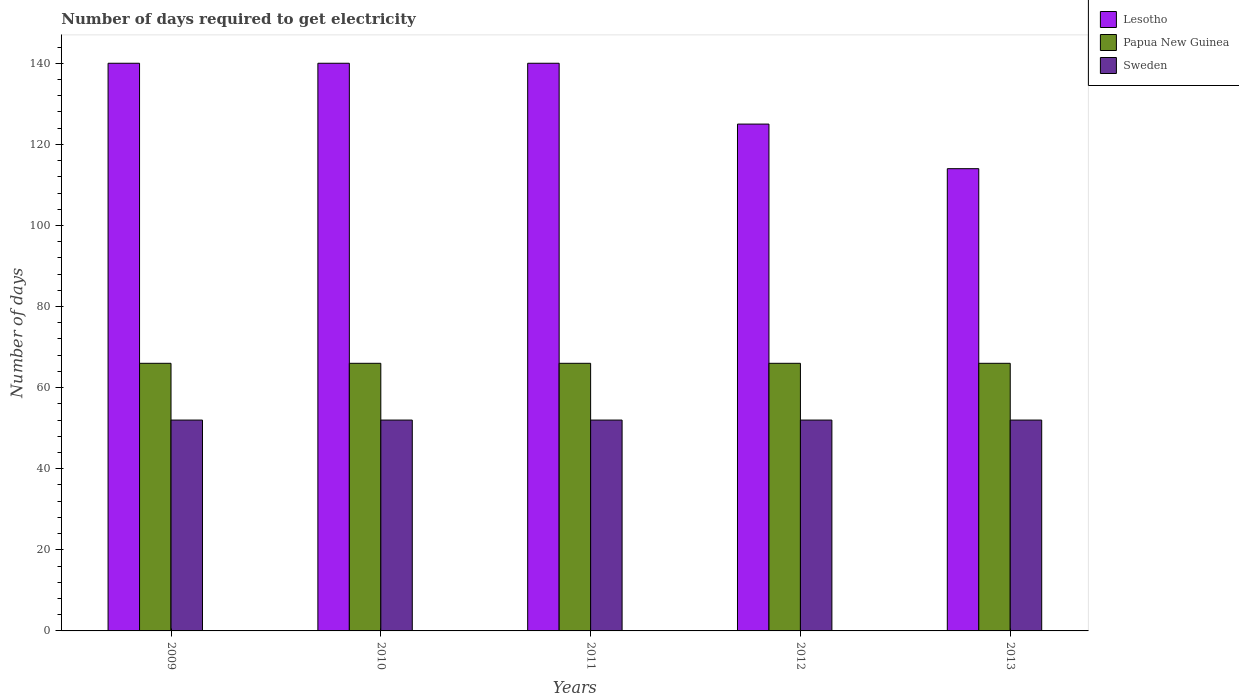Are the number of bars on each tick of the X-axis equal?
Your answer should be compact. Yes. How many bars are there on the 4th tick from the right?
Give a very brief answer. 3. In how many cases, is the number of bars for a given year not equal to the number of legend labels?
Keep it short and to the point. 0. What is the number of days required to get electricity in in Papua New Guinea in 2012?
Offer a very short reply. 66. Across all years, what is the maximum number of days required to get electricity in in Papua New Guinea?
Your answer should be compact. 66. Across all years, what is the minimum number of days required to get electricity in in Papua New Guinea?
Your answer should be compact. 66. In which year was the number of days required to get electricity in in Papua New Guinea maximum?
Keep it short and to the point. 2009. What is the total number of days required to get electricity in in Lesotho in the graph?
Keep it short and to the point. 659. What is the difference between the number of days required to get electricity in in Papua New Guinea in 2010 and that in 2013?
Give a very brief answer. 0. What is the difference between the number of days required to get electricity in in Papua New Guinea in 2011 and the number of days required to get electricity in in Lesotho in 2012?
Make the answer very short. -59. What is the average number of days required to get electricity in in Papua New Guinea per year?
Ensure brevity in your answer.  66. In the year 2011, what is the difference between the number of days required to get electricity in in Sweden and number of days required to get electricity in in Papua New Guinea?
Offer a very short reply. -14. What is the ratio of the number of days required to get electricity in in Sweden in 2011 to that in 2012?
Make the answer very short. 1. Is the number of days required to get electricity in in Lesotho in 2010 less than that in 2013?
Your response must be concise. No. Is the difference between the number of days required to get electricity in in Sweden in 2009 and 2010 greater than the difference between the number of days required to get electricity in in Papua New Guinea in 2009 and 2010?
Your response must be concise. No. What is the difference between the highest and the second highest number of days required to get electricity in in Papua New Guinea?
Ensure brevity in your answer.  0. What is the difference between the highest and the lowest number of days required to get electricity in in Papua New Guinea?
Your response must be concise. 0. Is the sum of the number of days required to get electricity in in Lesotho in 2009 and 2012 greater than the maximum number of days required to get electricity in in Papua New Guinea across all years?
Your answer should be very brief. Yes. What does the 1st bar from the left in 2009 represents?
Your response must be concise. Lesotho. What does the 1st bar from the right in 2010 represents?
Offer a very short reply. Sweden. How many years are there in the graph?
Offer a terse response. 5. Does the graph contain any zero values?
Your answer should be compact. No. Where does the legend appear in the graph?
Offer a terse response. Top right. What is the title of the graph?
Offer a very short reply. Number of days required to get electricity. What is the label or title of the X-axis?
Offer a terse response. Years. What is the label or title of the Y-axis?
Offer a terse response. Number of days. What is the Number of days in Lesotho in 2009?
Make the answer very short. 140. What is the Number of days in Papua New Guinea in 2009?
Your response must be concise. 66. What is the Number of days in Sweden in 2009?
Your response must be concise. 52. What is the Number of days of Lesotho in 2010?
Your response must be concise. 140. What is the Number of days in Sweden in 2010?
Offer a very short reply. 52. What is the Number of days in Lesotho in 2011?
Your response must be concise. 140. What is the Number of days of Papua New Guinea in 2011?
Keep it short and to the point. 66. What is the Number of days in Lesotho in 2012?
Make the answer very short. 125. What is the Number of days of Papua New Guinea in 2012?
Provide a short and direct response. 66. What is the Number of days of Lesotho in 2013?
Ensure brevity in your answer.  114. What is the Number of days of Papua New Guinea in 2013?
Provide a succinct answer. 66. Across all years, what is the maximum Number of days of Lesotho?
Offer a very short reply. 140. Across all years, what is the maximum Number of days in Papua New Guinea?
Ensure brevity in your answer.  66. Across all years, what is the minimum Number of days in Lesotho?
Keep it short and to the point. 114. What is the total Number of days of Lesotho in the graph?
Make the answer very short. 659. What is the total Number of days in Papua New Guinea in the graph?
Provide a succinct answer. 330. What is the total Number of days in Sweden in the graph?
Give a very brief answer. 260. What is the difference between the Number of days of Lesotho in 2009 and that in 2010?
Your response must be concise. 0. What is the difference between the Number of days of Lesotho in 2009 and that in 2011?
Your answer should be compact. 0. What is the difference between the Number of days in Sweden in 2009 and that in 2011?
Ensure brevity in your answer.  0. What is the difference between the Number of days of Papua New Guinea in 2009 and that in 2013?
Offer a terse response. 0. What is the difference between the Number of days in Sweden in 2010 and that in 2011?
Your answer should be compact. 0. What is the difference between the Number of days of Papua New Guinea in 2010 and that in 2012?
Provide a succinct answer. 0. What is the difference between the Number of days in Lesotho in 2010 and that in 2013?
Your response must be concise. 26. What is the difference between the Number of days of Papua New Guinea in 2010 and that in 2013?
Make the answer very short. 0. What is the difference between the Number of days of Papua New Guinea in 2011 and that in 2013?
Offer a very short reply. 0. What is the difference between the Number of days of Sweden in 2011 and that in 2013?
Give a very brief answer. 0. What is the difference between the Number of days of Lesotho in 2012 and that in 2013?
Your answer should be compact. 11. What is the difference between the Number of days of Lesotho in 2009 and the Number of days of Papua New Guinea in 2010?
Your answer should be compact. 74. What is the difference between the Number of days of Lesotho in 2009 and the Number of days of Sweden in 2010?
Offer a very short reply. 88. What is the difference between the Number of days in Papua New Guinea in 2009 and the Number of days in Sweden in 2010?
Provide a succinct answer. 14. What is the difference between the Number of days in Lesotho in 2009 and the Number of days in Sweden in 2011?
Your answer should be compact. 88. What is the difference between the Number of days in Papua New Guinea in 2009 and the Number of days in Sweden in 2011?
Provide a succinct answer. 14. What is the difference between the Number of days in Lesotho in 2009 and the Number of days in Papua New Guinea in 2013?
Your response must be concise. 74. What is the difference between the Number of days of Lesotho in 2010 and the Number of days of Sweden in 2011?
Ensure brevity in your answer.  88. What is the difference between the Number of days in Lesotho in 2010 and the Number of days in Papua New Guinea in 2012?
Your answer should be compact. 74. What is the difference between the Number of days in Papua New Guinea in 2010 and the Number of days in Sweden in 2012?
Your response must be concise. 14. What is the difference between the Number of days in Lesotho in 2010 and the Number of days in Papua New Guinea in 2013?
Make the answer very short. 74. What is the difference between the Number of days of Lesotho in 2011 and the Number of days of Papua New Guinea in 2012?
Offer a terse response. 74. What is the difference between the Number of days in Lesotho in 2011 and the Number of days in Sweden in 2012?
Make the answer very short. 88. What is the difference between the Number of days in Papua New Guinea in 2011 and the Number of days in Sweden in 2012?
Give a very brief answer. 14. What is the difference between the Number of days of Lesotho in 2011 and the Number of days of Papua New Guinea in 2013?
Offer a very short reply. 74. What is the difference between the Number of days in Lesotho in 2011 and the Number of days in Sweden in 2013?
Offer a very short reply. 88. What is the difference between the Number of days in Lesotho in 2012 and the Number of days in Papua New Guinea in 2013?
Keep it short and to the point. 59. What is the difference between the Number of days of Lesotho in 2012 and the Number of days of Sweden in 2013?
Provide a succinct answer. 73. What is the average Number of days in Lesotho per year?
Your response must be concise. 131.8. In the year 2009, what is the difference between the Number of days in Lesotho and Number of days in Sweden?
Provide a succinct answer. 88. In the year 2010, what is the difference between the Number of days of Lesotho and Number of days of Papua New Guinea?
Your response must be concise. 74. In the year 2010, what is the difference between the Number of days of Lesotho and Number of days of Sweden?
Offer a very short reply. 88. In the year 2010, what is the difference between the Number of days of Papua New Guinea and Number of days of Sweden?
Your answer should be very brief. 14. In the year 2011, what is the difference between the Number of days in Lesotho and Number of days in Papua New Guinea?
Your answer should be compact. 74. In the year 2012, what is the difference between the Number of days of Lesotho and Number of days of Papua New Guinea?
Your answer should be very brief. 59. In the year 2012, what is the difference between the Number of days in Lesotho and Number of days in Sweden?
Ensure brevity in your answer.  73. In the year 2013, what is the difference between the Number of days of Lesotho and Number of days of Papua New Guinea?
Keep it short and to the point. 48. What is the ratio of the Number of days of Papua New Guinea in 2009 to that in 2010?
Offer a very short reply. 1. What is the ratio of the Number of days in Lesotho in 2009 to that in 2012?
Your answer should be compact. 1.12. What is the ratio of the Number of days in Lesotho in 2009 to that in 2013?
Your answer should be very brief. 1.23. What is the ratio of the Number of days in Papua New Guinea in 2009 to that in 2013?
Your answer should be very brief. 1. What is the ratio of the Number of days in Sweden in 2010 to that in 2011?
Make the answer very short. 1. What is the ratio of the Number of days of Lesotho in 2010 to that in 2012?
Provide a succinct answer. 1.12. What is the ratio of the Number of days of Papua New Guinea in 2010 to that in 2012?
Ensure brevity in your answer.  1. What is the ratio of the Number of days in Sweden in 2010 to that in 2012?
Make the answer very short. 1. What is the ratio of the Number of days of Lesotho in 2010 to that in 2013?
Provide a succinct answer. 1.23. What is the ratio of the Number of days of Lesotho in 2011 to that in 2012?
Your answer should be very brief. 1.12. What is the ratio of the Number of days of Lesotho in 2011 to that in 2013?
Your answer should be very brief. 1.23. What is the ratio of the Number of days in Lesotho in 2012 to that in 2013?
Ensure brevity in your answer.  1.1. What is the ratio of the Number of days in Papua New Guinea in 2012 to that in 2013?
Your response must be concise. 1. What is the difference between the highest and the second highest Number of days in Papua New Guinea?
Give a very brief answer. 0. What is the difference between the highest and the second highest Number of days of Sweden?
Your answer should be compact. 0. What is the difference between the highest and the lowest Number of days in Papua New Guinea?
Make the answer very short. 0. What is the difference between the highest and the lowest Number of days in Sweden?
Provide a short and direct response. 0. 